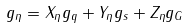<formula> <loc_0><loc_0><loc_500><loc_500>g _ { \eta } = X _ { \eta } g _ { q } + Y _ { \eta } g _ { s } + Z _ { \eta } g _ { G }</formula> 